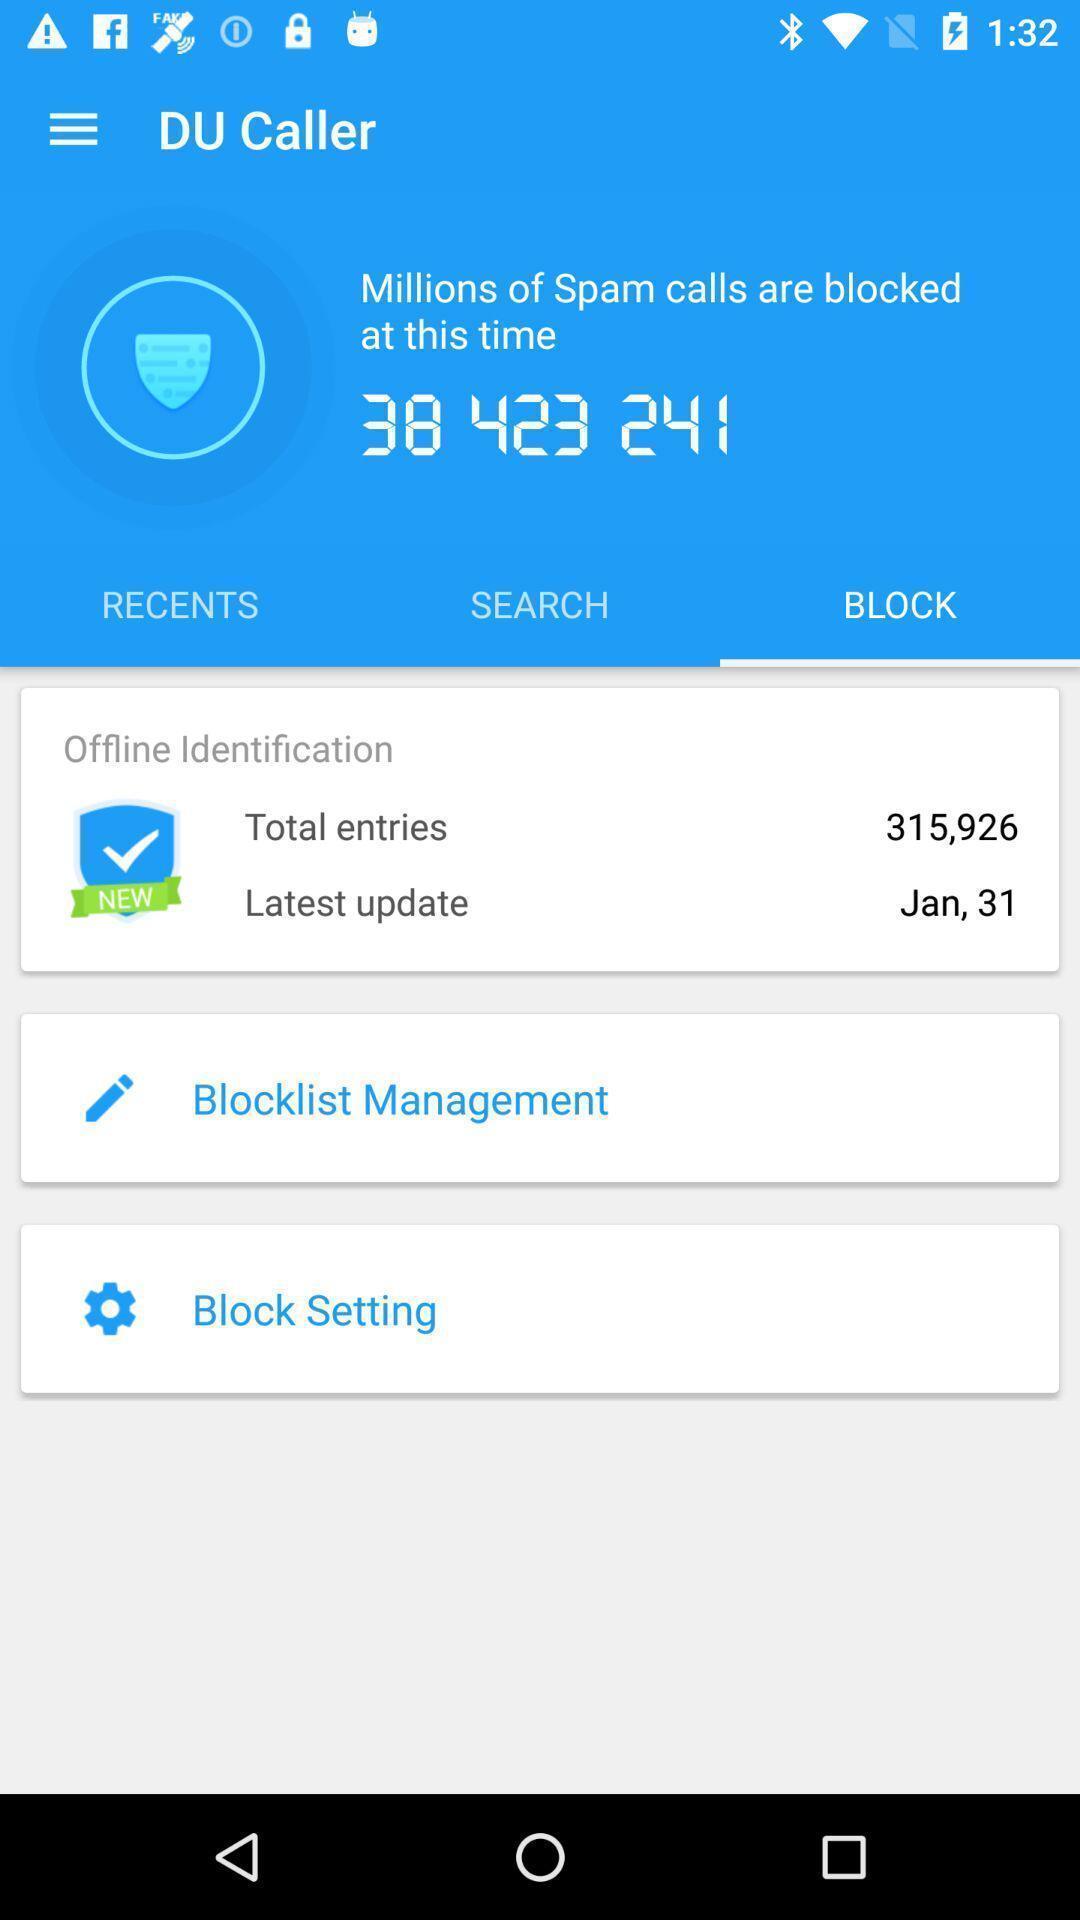Describe the content in this image. Page displaying to block contacts in app. 